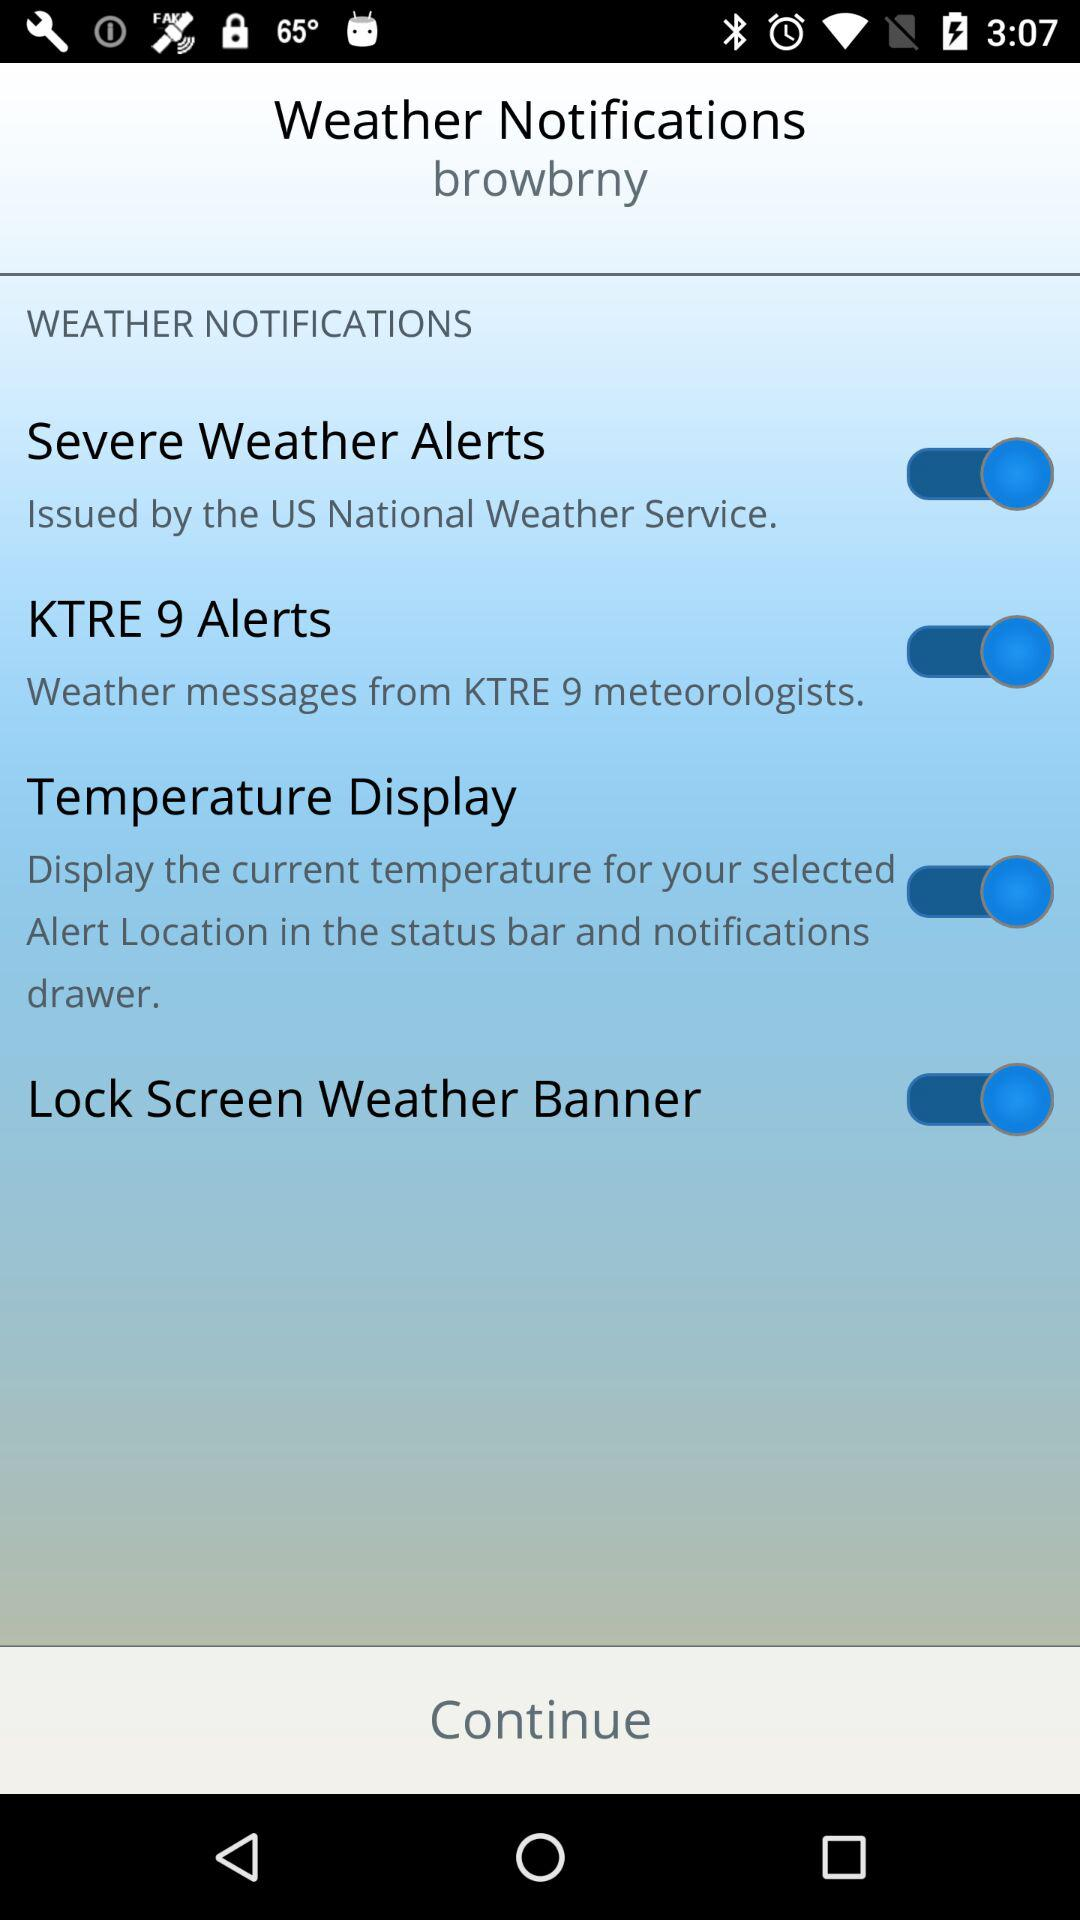What is the status of KTRE 9 alerts? The status is on. 